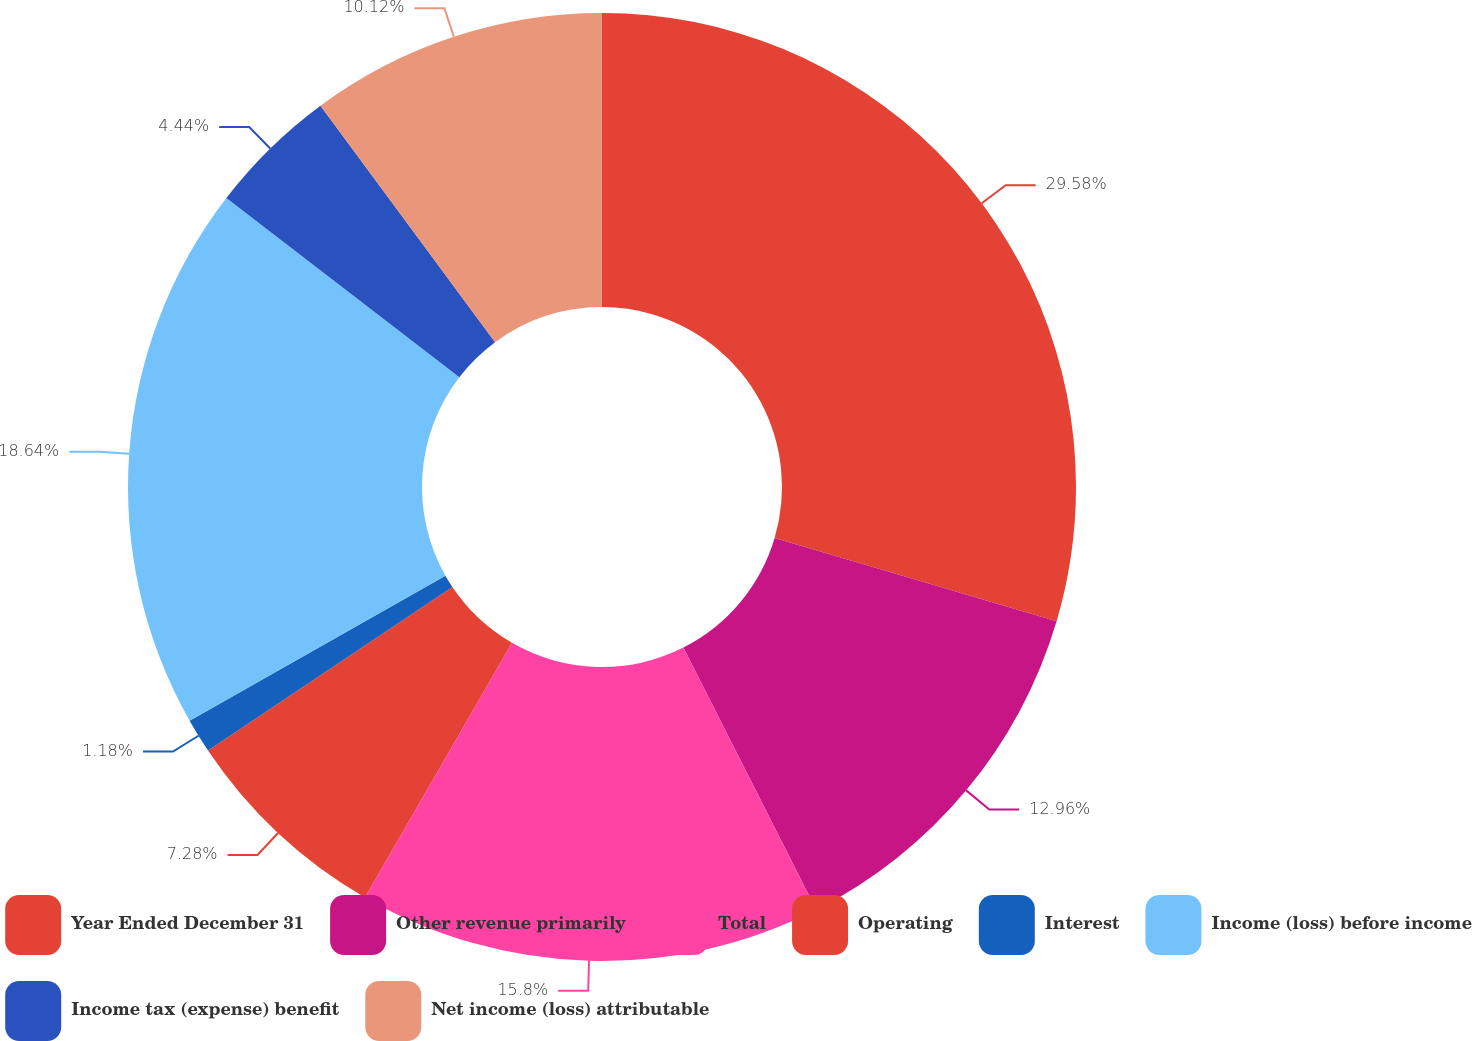Convert chart. <chart><loc_0><loc_0><loc_500><loc_500><pie_chart><fcel>Year Ended December 31<fcel>Other revenue primarily<fcel>Total<fcel>Operating<fcel>Interest<fcel>Income (loss) before income<fcel>Income tax (expense) benefit<fcel>Net income (loss) attributable<nl><fcel>29.57%<fcel>12.96%<fcel>15.8%<fcel>7.28%<fcel>1.18%<fcel>18.64%<fcel>4.44%<fcel>10.12%<nl></chart> 